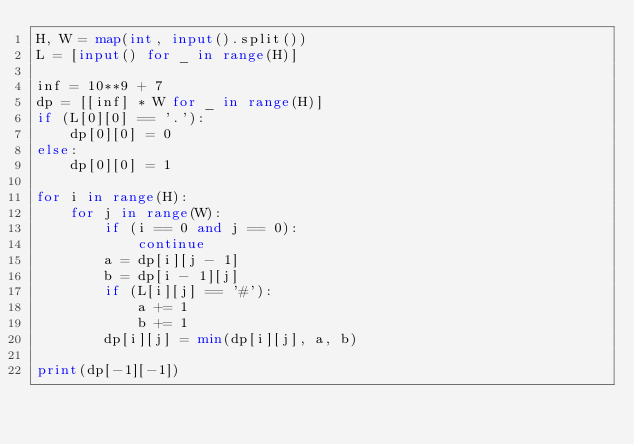Convert code to text. <code><loc_0><loc_0><loc_500><loc_500><_Python_>H, W = map(int, input().split())
L = [input() for _ in range(H)]

inf = 10**9 + 7
dp = [[inf] * W for _ in range(H)]
if (L[0][0] == '.'):
    dp[0][0] = 0
else:
    dp[0][0] = 1

for i in range(H):
    for j in range(W):
        if (i == 0 and j == 0):
            continue
        a = dp[i][j - 1]
        b = dp[i - 1][j]
        if (L[i][j] == '#'):
            a += 1
            b += 1
        dp[i][j] = min(dp[i][j], a, b)

print(dp[-1][-1])</code> 